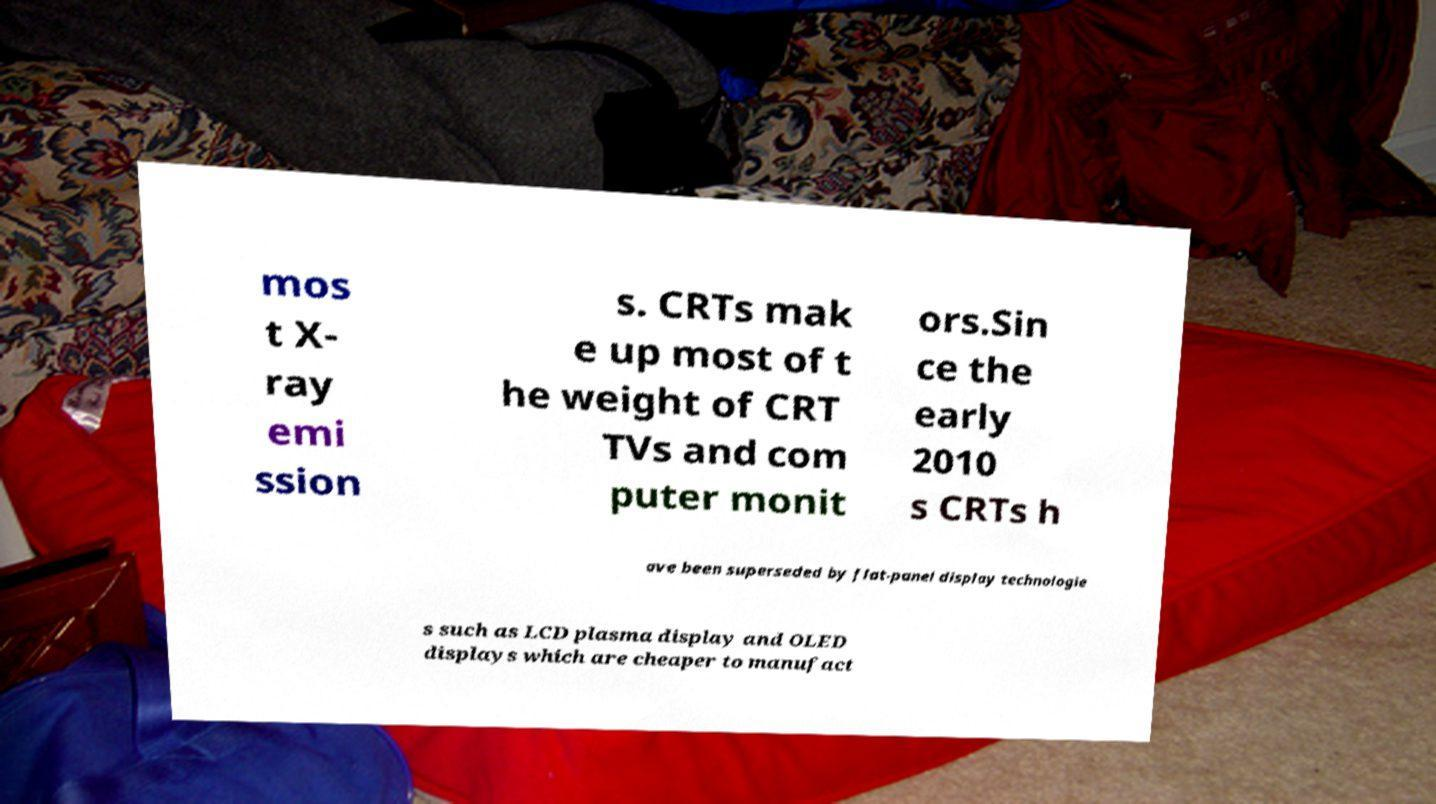Please read and relay the text visible in this image. What does it say? mos t X- ray emi ssion s. CRTs mak e up most of t he weight of CRT TVs and com puter monit ors.Sin ce the early 2010 s CRTs h ave been superseded by flat-panel display technologie s such as LCD plasma display and OLED displays which are cheaper to manufact 